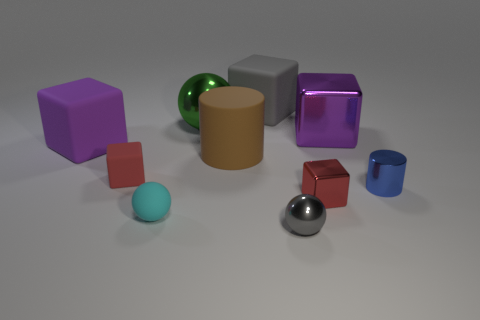Which objects stand out the most due to their brightness or reflectivity? The objects that stand out the most due to their reflectivity are the green sphere and the silver sphere. Their shiny surfaces catch the light, giving them a luminous appearance in contrast to the more matte textured objects. How does the lighting affect the appearance of the objects? The lighting in the image appears to come from the upper left, casting soft shadows to the right of the objects. This highlights contours and gives the objects a three-dimensional feel. The shiny surfaces, such as those of the green and silver spheres, reflect the light, making them gleam and enhancing their visibility. 